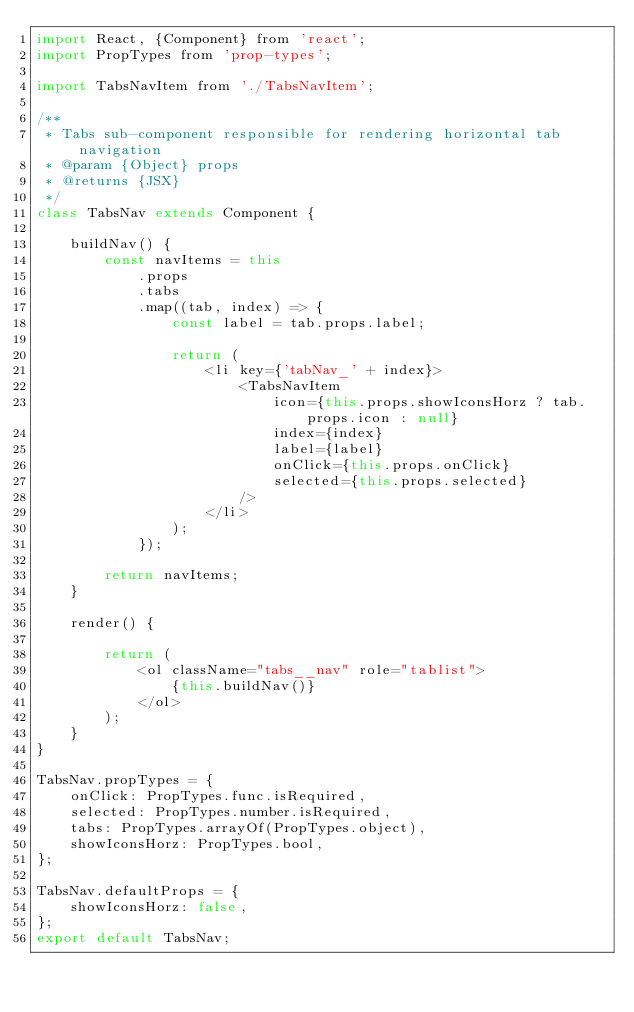<code> <loc_0><loc_0><loc_500><loc_500><_JavaScript_>import React, {Component} from 'react';
import PropTypes from 'prop-types';

import TabsNavItem from './TabsNavItem';

/**
 * Tabs sub-component responsible for rendering horizontal tab navigation
 * @param {Object} props
 * @returns {JSX}
 */
class TabsNav extends Component {

    buildNav() {
        const navItems = this
            .props
            .tabs
            .map((tab, index) => {
                const label = tab.props.label;

                return (
                    <li key={'tabNav_' + index}>
                        <TabsNavItem
                            icon={this.props.showIconsHorz ? tab.props.icon : null}
                            index={index}
                            label={label}
                            onClick={this.props.onClick}
                            selected={this.props.selected}
                        />
                    </li>
                );
            });

        return navItems;
    }

    render() {

        return (
            <ol className="tabs__nav" role="tablist">
                {this.buildNav()}
            </ol>
        );
    }
}

TabsNav.propTypes = {
    onClick: PropTypes.func.isRequired,
    selected: PropTypes.number.isRequired,
    tabs: PropTypes.arrayOf(PropTypes.object),
    showIconsHorz: PropTypes.bool,
};

TabsNav.defaultProps = {
    showIconsHorz: false,
};
export default TabsNav;
</code> 